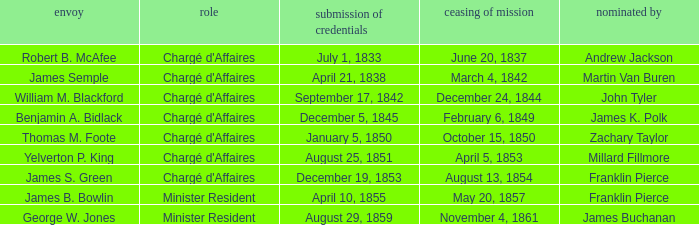What Title has a Termination of Mission for August 13, 1854? Chargé d'Affaires. 